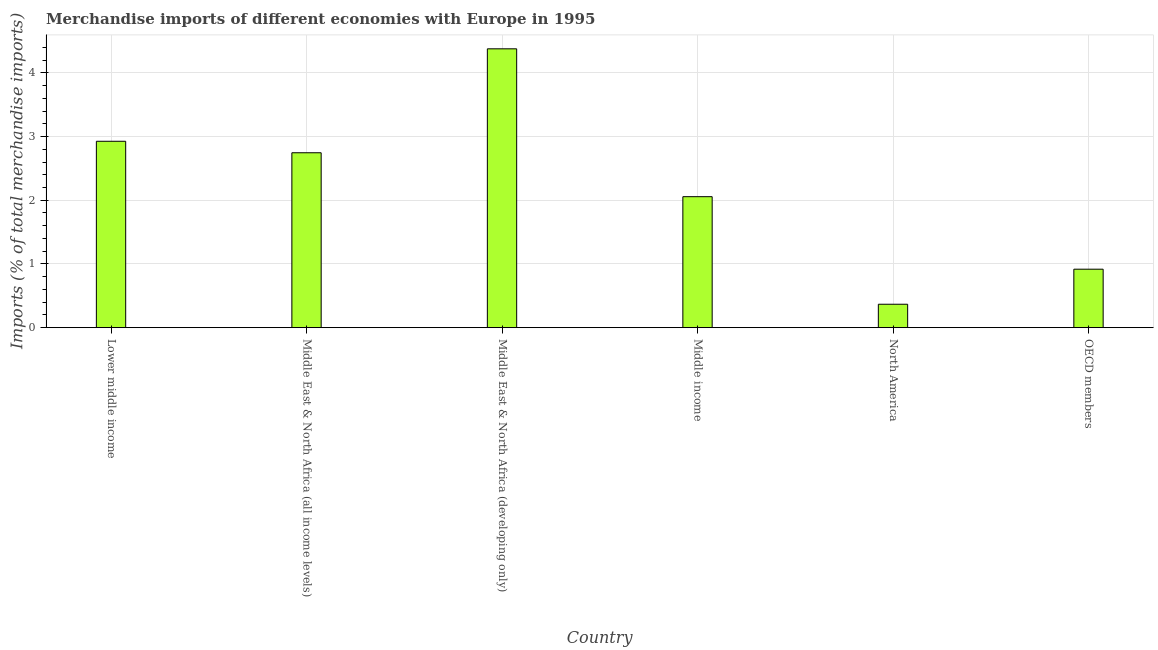Does the graph contain any zero values?
Your answer should be very brief. No. Does the graph contain grids?
Make the answer very short. Yes. What is the title of the graph?
Your response must be concise. Merchandise imports of different economies with Europe in 1995. What is the label or title of the X-axis?
Keep it short and to the point. Country. What is the label or title of the Y-axis?
Your answer should be compact. Imports (% of total merchandise imports). What is the merchandise imports in Lower middle income?
Your response must be concise. 2.93. Across all countries, what is the maximum merchandise imports?
Offer a terse response. 4.38. Across all countries, what is the minimum merchandise imports?
Offer a terse response. 0.37. In which country was the merchandise imports maximum?
Offer a terse response. Middle East & North Africa (developing only). What is the sum of the merchandise imports?
Ensure brevity in your answer.  13.39. What is the difference between the merchandise imports in Lower middle income and OECD members?
Provide a short and direct response. 2.01. What is the average merchandise imports per country?
Ensure brevity in your answer.  2.23. What is the median merchandise imports?
Make the answer very short. 2.4. What is the ratio of the merchandise imports in Lower middle income to that in North America?
Provide a short and direct response. 7.96. What is the difference between the highest and the second highest merchandise imports?
Give a very brief answer. 1.45. What is the difference between the highest and the lowest merchandise imports?
Offer a terse response. 4.01. In how many countries, is the merchandise imports greater than the average merchandise imports taken over all countries?
Your answer should be very brief. 3. How many countries are there in the graph?
Offer a terse response. 6. What is the difference between two consecutive major ticks on the Y-axis?
Offer a very short reply. 1. Are the values on the major ticks of Y-axis written in scientific E-notation?
Your answer should be very brief. No. What is the Imports (% of total merchandise imports) in Lower middle income?
Offer a very short reply. 2.93. What is the Imports (% of total merchandise imports) of Middle East & North Africa (all income levels)?
Provide a succinct answer. 2.75. What is the Imports (% of total merchandise imports) in Middle East & North Africa (developing only)?
Give a very brief answer. 4.38. What is the Imports (% of total merchandise imports) in Middle income?
Offer a terse response. 2.06. What is the Imports (% of total merchandise imports) in North America?
Your answer should be compact. 0.37. What is the Imports (% of total merchandise imports) in OECD members?
Your answer should be very brief. 0.92. What is the difference between the Imports (% of total merchandise imports) in Lower middle income and Middle East & North Africa (all income levels)?
Offer a terse response. 0.18. What is the difference between the Imports (% of total merchandise imports) in Lower middle income and Middle East & North Africa (developing only)?
Make the answer very short. -1.45. What is the difference between the Imports (% of total merchandise imports) in Lower middle income and Middle income?
Your response must be concise. 0.87. What is the difference between the Imports (% of total merchandise imports) in Lower middle income and North America?
Keep it short and to the point. 2.56. What is the difference between the Imports (% of total merchandise imports) in Lower middle income and OECD members?
Give a very brief answer. 2.01. What is the difference between the Imports (% of total merchandise imports) in Middle East & North Africa (all income levels) and Middle East & North Africa (developing only)?
Give a very brief answer. -1.63. What is the difference between the Imports (% of total merchandise imports) in Middle East & North Africa (all income levels) and Middle income?
Provide a succinct answer. 0.69. What is the difference between the Imports (% of total merchandise imports) in Middle East & North Africa (all income levels) and North America?
Your answer should be very brief. 2.38. What is the difference between the Imports (% of total merchandise imports) in Middle East & North Africa (all income levels) and OECD members?
Offer a terse response. 1.83. What is the difference between the Imports (% of total merchandise imports) in Middle East & North Africa (developing only) and Middle income?
Your answer should be very brief. 2.32. What is the difference between the Imports (% of total merchandise imports) in Middle East & North Africa (developing only) and North America?
Give a very brief answer. 4.01. What is the difference between the Imports (% of total merchandise imports) in Middle East & North Africa (developing only) and OECD members?
Give a very brief answer. 3.46. What is the difference between the Imports (% of total merchandise imports) in Middle income and North America?
Your response must be concise. 1.69. What is the difference between the Imports (% of total merchandise imports) in Middle income and OECD members?
Your answer should be very brief. 1.14. What is the difference between the Imports (% of total merchandise imports) in North America and OECD members?
Your answer should be very brief. -0.55. What is the ratio of the Imports (% of total merchandise imports) in Lower middle income to that in Middle East & North Africa (all income levels)?
Offer a very short reply. 1.07. What is the ratio of the Imports (% of total merchandise imports) in Lower middle income to that in Middle East & North Africa (developing only)?
Give a very brief answer. 0.67. What is the ratio of the Imports (% of total merchandise imports) in Lower middle income to that in Middle income?
Your response must be concise. 1.42. What is the ratio of the Imports (% of total merchandise imports) in Lower middle income to that in North America?
Your answer should be compact. 7.96. What is the ratio of the Imports (% of total merchandise imports) in Lower middle income to that in OECD members?
Keep it short and to the point. 3.19. What is the ratio of the Imports (% of total merchandise imports) in Middle East & North Africa (all income levels) to that in Middle East & North Africa (developing only)?
Offer a terse response. 0.63. What is the ratio of the Imports (% of total merchandise imports) in Middle East & North Africa (all income levels) to that in Middle income?
Offer a terse response. 1.33. What is the ratio of the Imports (% of total merchandise imports) in Middle East & North Africa (all income levels) to that in North America?
Ensure brevity in your answer.  7.47. What is the ratio of the Imports (% of total merchandise imports) in Middle East & North Africa (all income levels) to that in OECD members?
Offer a very short reply. 2.99. What is the ratio of the Imports (% of total merchandise imports) in Middle East & North Africa (developing only) to that in Middle income?
Provide a succinct answer. 2.13. What is the ratio of the Imports (% of total merchandise imports) in Middle East & North Africa (developing only) to that in North America?
Offer a terse response. 11.9. What is the ratio of the Imports (% of total merchandise imports) in Middle East & North Africa (developing only) to that in OECD members?
Your response must be concise. 4.77. What is the ratio of the Imports (% of total merchandise imports) in Middle income to that in North America?
Keep it short and to the point. 5.59. What is the ratio of the Imports (% of total merchandise imports) in Middle income to that in OECD members?
Your answer should be compact. 2.24. What is the ratio of the Imports (% of total merchandise imports) in North America to that in OECD members?
Provide a succinct answer. 0.4. 